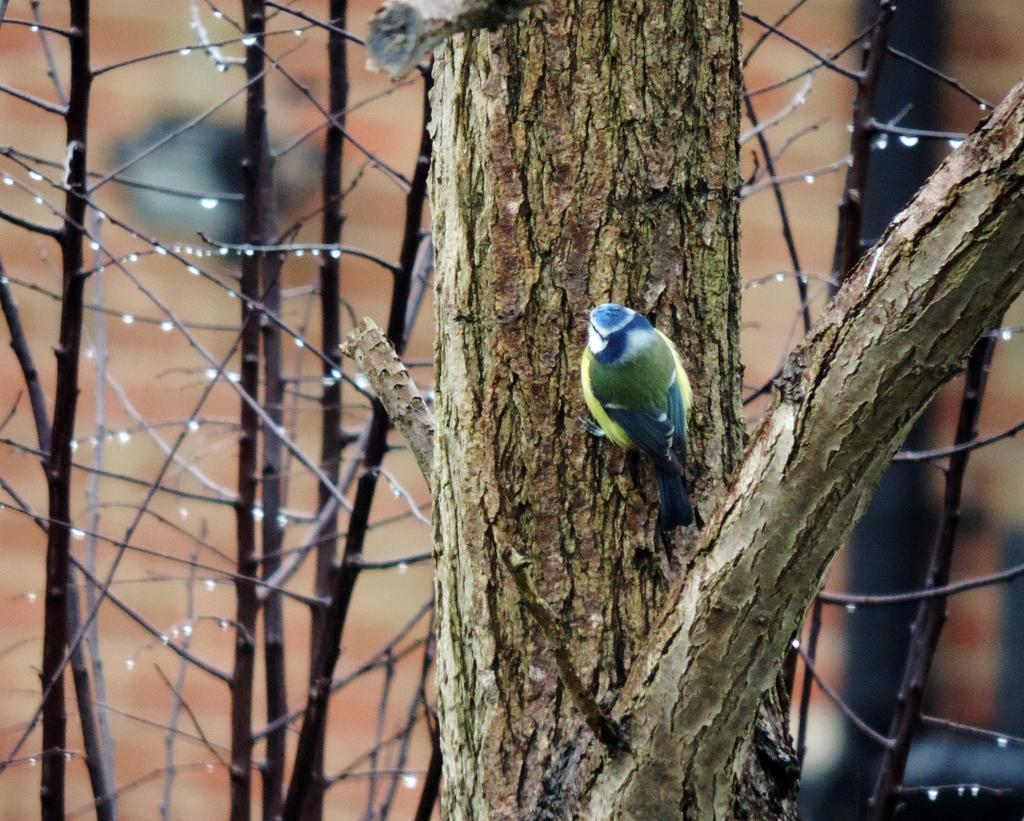What animal can be seen in the image? There is a bird in the image. Where is the bird located? The bird is on a tree trunk. What can be observed on the branches of the tree? There are water droplets on the branches. How would you describe the background of the image? The background of the image is blurred. What type of blade is being used to stop the bird from flying away in the image? There is no blade or attempt to stop the bird from flying away in the image. 